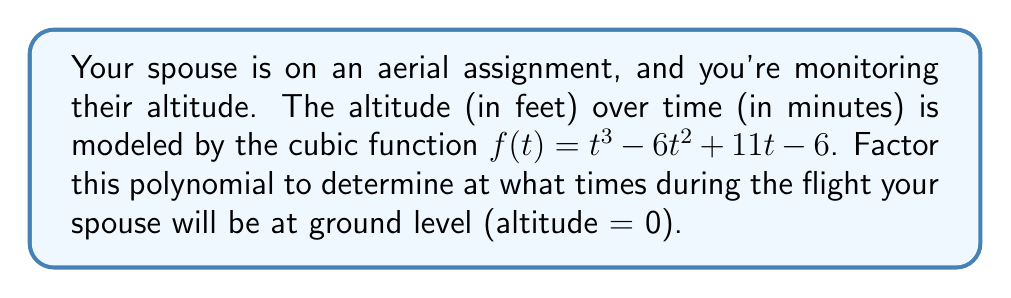Show me your answer to this math problem. To factor this cubic polynomial and find when the altitude is zero, we'll follow these steps:

1) First, we need to find the roots of the equation $f(t) = 0$:

   $t^3 - 6t^2 + 11t - 6 = 0$

2) We can use the rational root theorem to find potential roots. The factors of the constant term (6) are: ±1, ±2, ±3, ±6.

3) Testing these values, we find that $t = 1$ is a root:

   $f(1) = 1^3 - 6(1)^2 + 11(1) - 6 = 1 - 6 + 11 - 6 = 0$

4) Now we can factor out $(t-1)$:

   $t^3 - 6t^2 + 11t - 6 = (t-1)(t^2 - 5t + 6)$

5) The quadratic factor $t^2 - 5t + 6$ can be factored further:

   $t^2 - 5t + 6 = (t-2)(t-3)$

6) Therefore, the fully factored polynomial is:

   $f(t) = (t-1)(t-2)(t-3)$

7) Setting this equal to zero:

   $(t-1)(t-2)(t-3) = 0$

8) The solutions are $t = 1$, $t = 2$, and $t = 3$.

These are the times (in minutes) when your spouse's altitude will be zero, i.e., at ground level.
Answer: $f(t) = (t-1)(t-2)(t-3)$; Ground level at $t = 1$, $2$, and $3$ minutes 